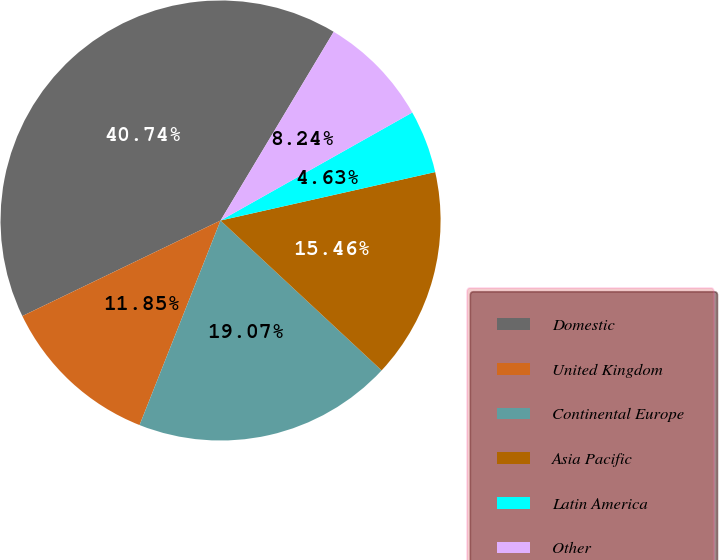<chart> <loc_0><loc_0><loc_500><loc_500><pie_chart><fcel>Domestic<fcel>United Kingdom<fcel>Continental Europe<fcel>Asia Pacific<fcel>Latin America<fcel>Other<nl><fcel>40.74%<fcel>11.85%<fcel>19.07%<fcel>15.46%<fcel>4.63%<fcel>8.24%<nl></chart> 